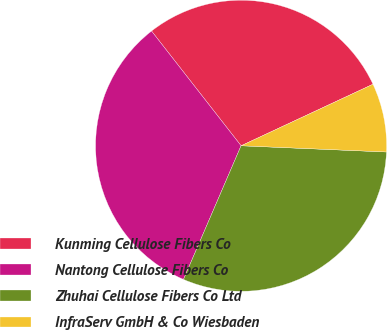Convert chart to OTSL. <chart><loc_0><loc_0><loc_500><loc_500><pie_chart><fcel>Kunming Cellulose Fibers Co<fcel>Nantong Cellulose Fibers Co<fcel>Zhuhai Cellulose Fibers Co Ltd<fcel>InfraServ GmbH & Co Wiesbaden<nl><fcel>28.6%<fcel>32.98%<fcel>30.79%<fcel>7.63%<nl></chart> 